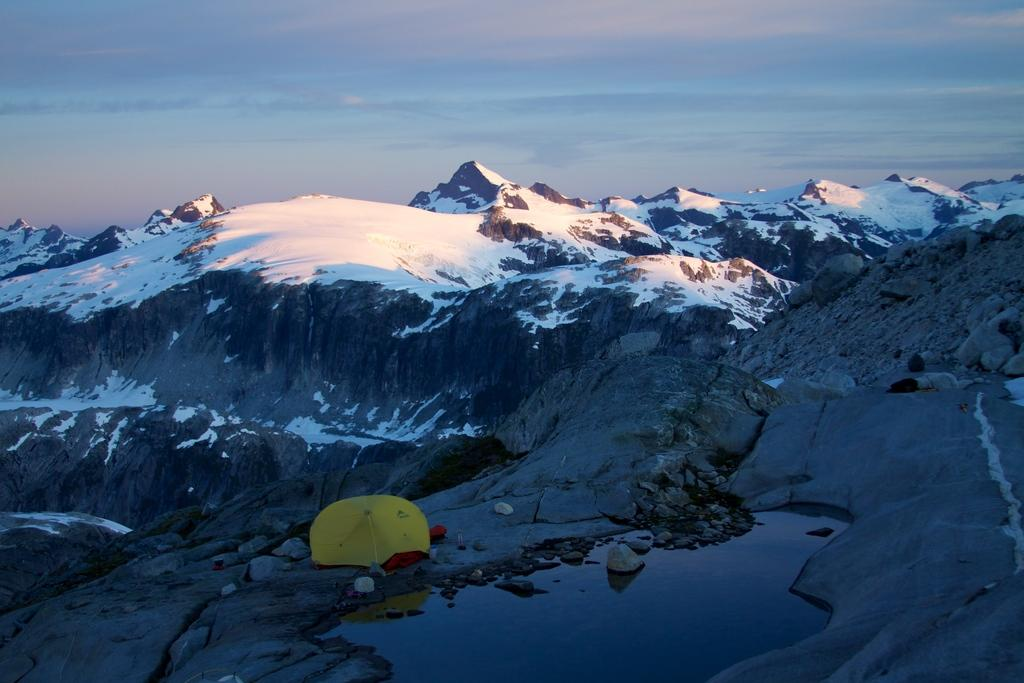What type of shelter is present in the image? There is a tent in the image. What natural element can be seen in the image? There is water visible in the image. What type of terrain is present in the image? There is snow on the rocks in the image. What is visible at the top of the image? The sky is visible at the top of the image. What type of stew is being cooked in the image? There is no stew present in the image; it features a tent, water, snow on rocks, and a visible sky. What color is the yarn used to decorate the tent in the image? There is no yarn present in the image; it only features a tent, water, snow on rocks, and a visible sky. 